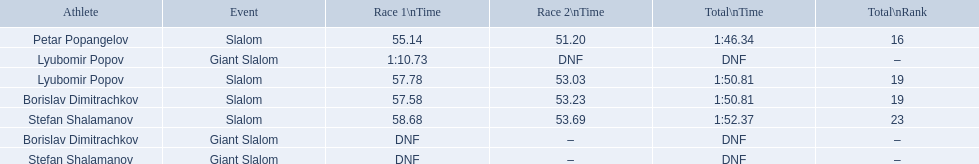Which event is the giant slalom? Giant Slalom, Giant Slalom, Giant Slalom. Which one is lyubomir popov? Lyubomir Popov. What is race 1 tim? 1:10.73. 